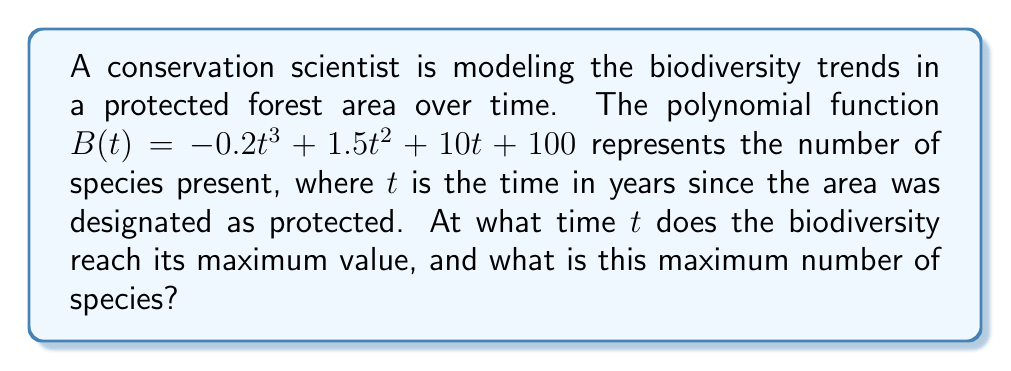Provide a solution to this math problem. To find the maximum value of the biodiversity function, we need to follow these steps:

1) First, we need to find the derivative of $B(t)$:
   $$B'(t) = -0.6t^2 + 3t + 10$$

2) To find the critical points, we set $B'(t) = 0$ and solve for $t$:
   $$-0.6t^2 + 3t + 10 = 0$$

3) This is a quadratic equation. We can solve it using the quadratic formula:
   $$t = \frac{-b \pm \sqrt{b^2 - 4ac}}{2a}$$
   where $a = -0.6$, $b = 3$, and $c = 10$

4) Substituting these values:
   $$t = \frac{-3 \pm \sqrt{3^2 - 4(-0.6)(10)}}{2(-0.6)}$$
   $$= \frac{-3 \pm \sqrt{9 + 24}}{-1.2}$$
   $$= \frac{-3 \pm \sqrt{33}}{-1.2}$$

5) This gives us two solutions:
   $$t_1 = \frac{-3 + \sqrt{33}}{-1.2} \approx 5.29$$
   $$t_2 = \frac{-3 - \sqrt{33}}{-1.2} \approx -0.29$$

6) Since time cannot be negative in this context, we discard the negative solution. Therefore, the biodiversity reaches its maximum at $t \approx 5.29$ years.

7) To find the maximum number of species, we substitute this value of $t$ back into the original function:
   $$B(5.29) = -0.2(5.29)^3 + 1.5(5.29)^2 + 10(5.29) + 100$$
   $$\approx 157.63$$

Therefore, the biodiversity reaches its maximum of approximately 158 species after about 5.29 years.
Answer: Maximum at $t \approx 5.29$ years, $B(t) \approx 158$ species 